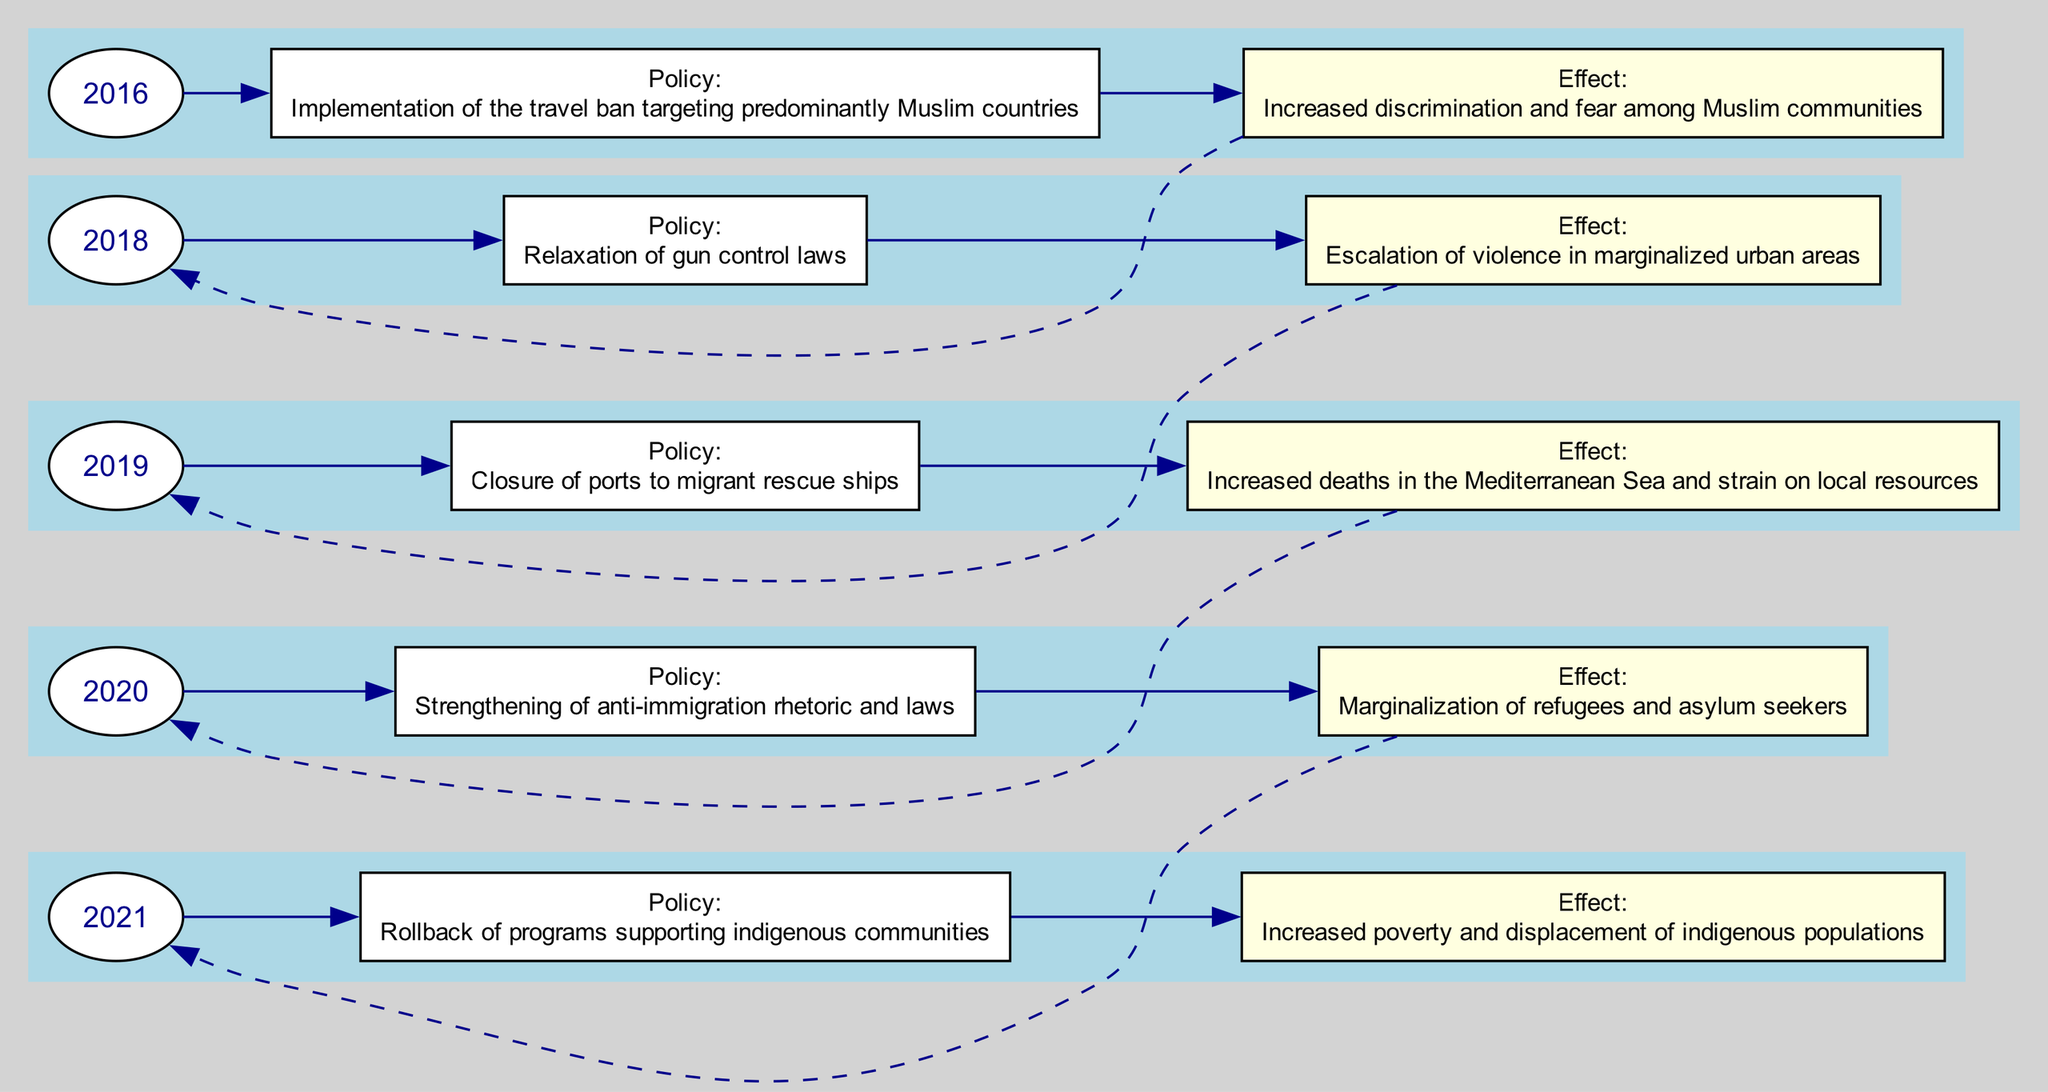What year was the election of Donald Trump? The diagram indicates the event of Donald Trump's election in the year 2016, which is labeled at the starting node on the left side of the timeline.
Answer: 2016 What policy change was enacted in Brazil in 2018? According to the diagram, the policy change in Brazil in 2018 was the relaxation of gun control laws. This information is present in the node linked to the event of Jair Bolsonaro's election.
Answer: Relaxation of gun control laws How many events are represented in the timeline? By counting the individual years listed in the diagram from 2016 to 2021, there are a total of five distinct events shown in this timeline.
Answer: 5 What is the effect of the 2020 election of Viktor Orbán? The diagram specifies that the effect of Viktor Orbán’s re-election in 2020 was the marginalization of refugees and asylum seekers. This is linked to the corresponding effect node in the sequence.
Answer: Marginalization of refugees and asylum seekers What connects the events in the diagram? The diagram uses dashed edges to connect the effects of one year to the year of the next event, demonstrating the sequential nature of the policy impacts over time.
Answer: Dashed edges What was the policy change linked to the rise of Matteo Salvini in 2019? Referring to the 2019 node in the diagram associated with Matteo Salvini, the policy change was the closure of ports to migrant rescue ships. This is clearly stated in that segment of the diagram.
Answer: Closure of ports to migrant rescue ships What effect did the rollback of programs supported by López Obrador have? The diagram outlines that the rollback of programs supporting indigenous communities led to increased poverty and displacement of indigenous populations, which is detailed in the effect node linked to 2021.
Answer: Increased poverty and displacement of indigenous populations Which two years have effects related to immigration policy? Following the timeline, the years 2019 (Matteo Salvini's event) and 2020 (Viktor Orbán's event) both relate to immigration policy, as both policy changes have significant consequences for immigrants and asylum seekers.
Answer: 2019 and 2020 What type of laws were strengthened in Hungary after Orbán's re-election? The diagram indicates that after the re-election of Viktor Orbán in Hungary in 2020, there was a strengthening of anti-immigration rhetoric and laws, which is stated clearly in the policy change node for that year.
Answer: Anti-immigration rhetoric and laws 